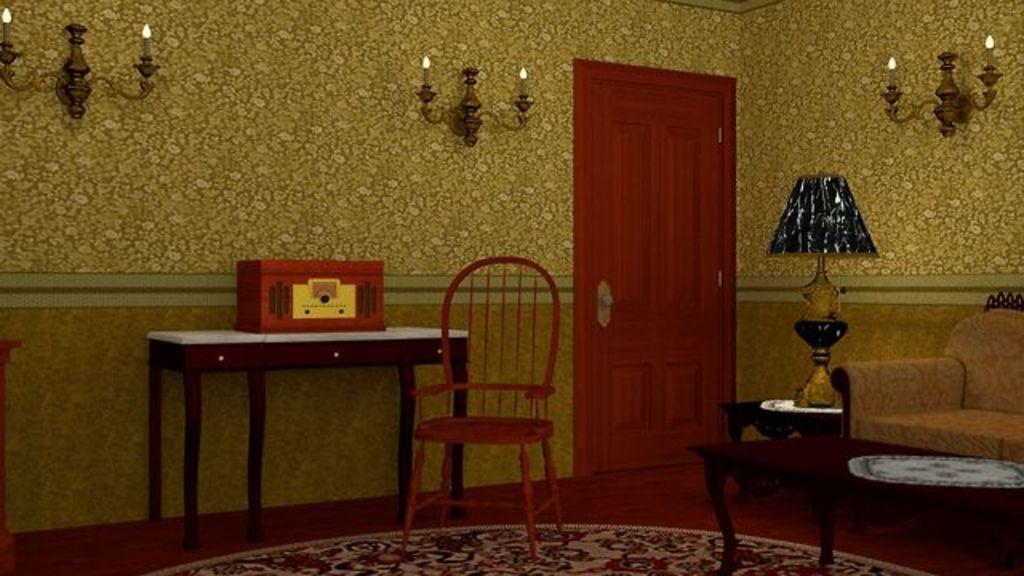In one or two sentences, can you explain what this image depicts? In this image there is the chair, there is a table truncated towards the right of the image, there is a couch truncated towards the right of the image, there is a lamp on the table, there is an object on the table, there is a mat truncated towards the bottom of the image, there is the door, there is wall truncated towards the top of the image, there is wall truncated towards the right of the image, there is wall truncated towards the left of the image, there are objects on the wall, there is an object truncated towards the left of the image. 